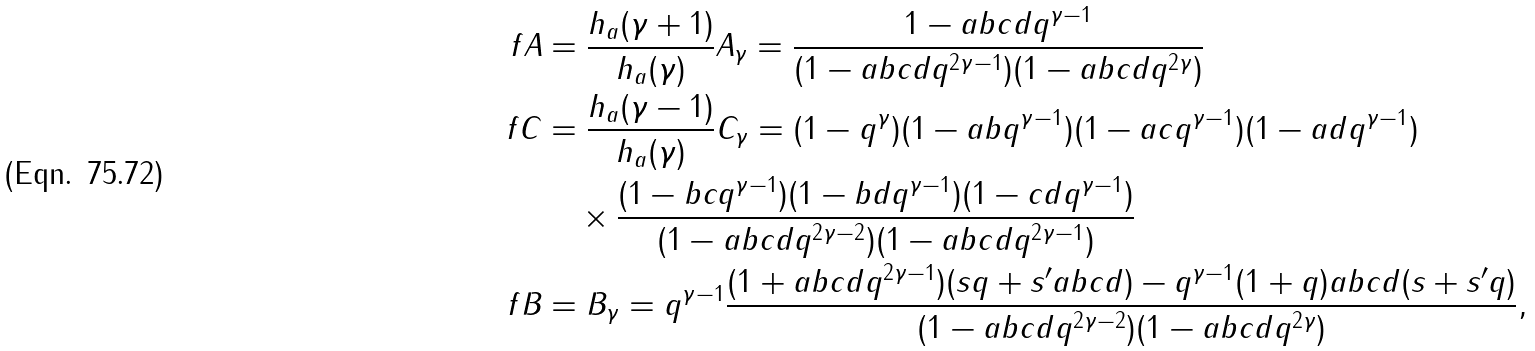Convert formula to latex. <formula><loc_0><loc_0><loc_500><loc_500>\ f A & = \frac { h _ { a } ( \gamma + 1 ) } { h _ { a } ( \gamma ) } A _ { \gamma } = \frac { 1 - a b c d q ^ { \gamma - 1 } } { ( 1 - a b c d q ^ { 2 \gamma - 1 } ) ( 1 - a b c d q ^ { 2 \gamma } ) } \\ \ f C & = \frac { h _ { a } ( \gamma - 1 ) } { h _ { a } ( \gamma ) } C _ { \gamma } = ( 1 - q ^ { \gamma } ) ( 1 - a b q ^ { \gamma - 1 } ) ( 1 - a c q ^ { \gamma - 1 } ) ( 1 - a d q ^ { \gamma - 1 } ) \\ & \quad \times \frac { ( 1 - b c q ^ { \gamma - 1 } ) ( 1 - b d q ^ { \gamma - 1 } ) ( 1 - c d q ^ { \gamma - 1 } ) } { ( 1 - a b c d q ^ { 2 \gamma - 2 } ) ( 1 - a b c d q ^ { 2 \gamma - 1 } ) } \\ \ f B & = B _ { \gamma } = q ^ { \gamma - 1 } \frac { ( 1 + a b c d q ^ { 2 \gamma - 1 } ) ( s q + s ^ { \prime } a b c d ) - q ^ { \gamma - 1 } ( 1 + q ) a b c d ( s + s ^ { \prime } q ) } { ( 1 - a b c d q ^ { 2 \gamma - 2 } ) ( 1 - a b c d q ^ { 2 \gamma } ) } ,</formula> 